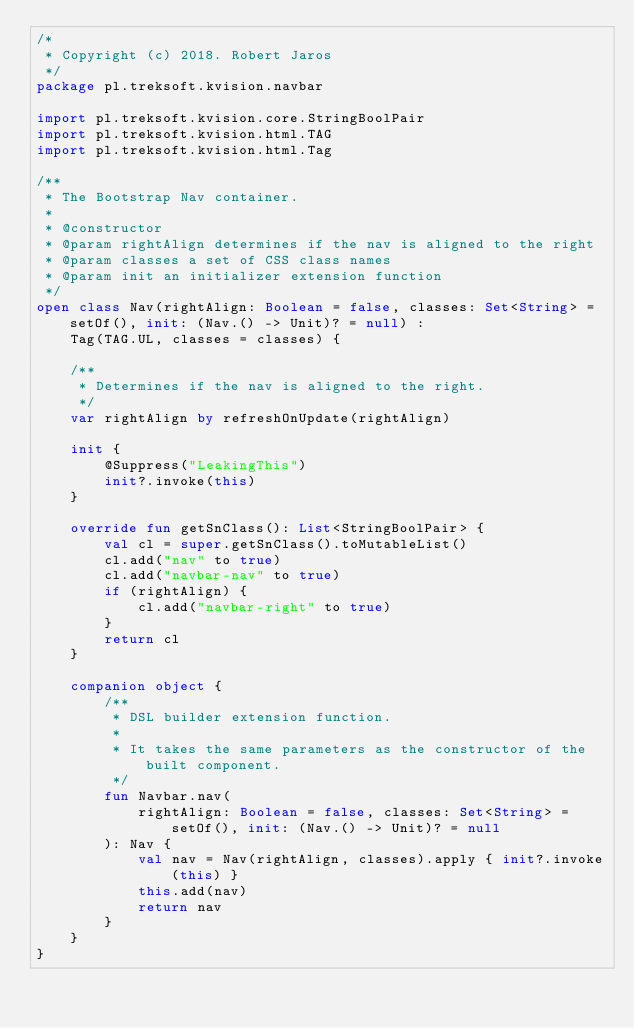<code> <loc_0><loc_0><loc_500><loc_500><_Kotlin_>/*
 * Copyright (c) 2018. Robert Jaros
 */
package pl.treksoft.kvision.navbar

import pl.treksoft.kvision.core.StringBoolPair
import pl.treksoft.kvision.html.TAG
import pl.treksoft.kvision.html.Tag

/**
 * The Bootstrap Nav container.
 *
 * @constructor
 * @param rightAlign determines if the nav is aligned to the right
 * @param classes a set of CSS class names
 * @param init an initializer extension function
 */
open class Nav(rightAlign: Boolean = false, classes: Set<String> = setOf(), init: (Nav.() -> Unit)? = null) :
    Tag(TAG.UL, classes = classes) {

    /**
     * Determines if the nav is aligned to the right.
     */
    var rightAlign by refreshOnUpdate(rightAlign)

    init {
        @Suppress("LeakingThis")
        init?.invoke(this)
    }

    override fun getSnClass(): List<StringBoolPair> {
        val cl = super.getSnClass().toMutableList()
        cl.add("nav" to true)
        cl.add("navbar-nav" to true)
        if (rightAlign) {
            cl.add("navbar-right" to true)
        }
        return cl
    }

    companion object {
        /**
         * DSL builder extension function.
         *
         * It takes the same parameters as the constructor of the built component.
         */
        fun Navbar.nav(
            rightAlign: Boolean = false, classes: Set<String> = setOf(), init: (Nav.() -> Unit)? = null
        ): Nav {
            val nav = Nav(rightAlign, classes).apply { init?.invoke(this) }
            this.add(nav)
            return nav
        }
    }
}
</code> 